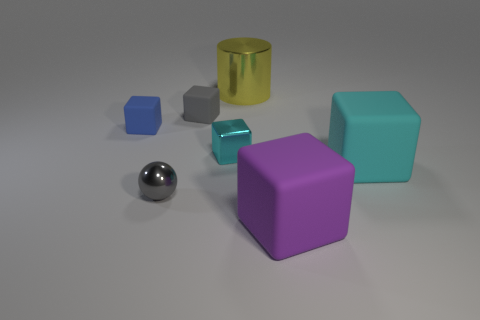What color is the small rubber cube that is in front of the tiny rubber thing right of the metallic object that is left of the small cyan block? The small rubber cube positioned in front of the tiny rubber object, which is to the right of the metallic sphere and to the left of the small cyan block, is purple. 